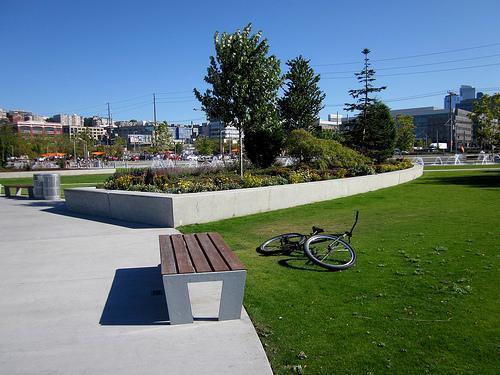How many people are in this photograph?
Give a very brief answer. 0. How many bicycles are in this photograph?
Give a very brief answer. 1. How many benches are in this photograph?
Give a very brief answer. 2. 